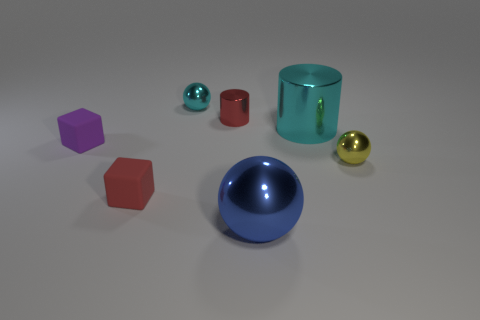What number of other things are there of the same color as the large metal cylinder?
Make the answer very short. 1. There is a tiny block that is the same color as the tiny cylinder; what is its material?
Provide a succinct answer. Rubber. How many tiny objects have the same color as the tiny shiny cylinder?
Your answer should be compact. 1. Does the large thing that is behind the small red cube have the same color as the sphere behind the big cylinder?
Give a very brief answer. Yes. There is a cylinder to the right of the red shiny cylinder; what is its size?
Make the answer very short. Large. Is there any other thing that has the same color as the big cylinder?
Ensure brevity in your answer.  Yes. There is a thing that is in front of the small matte thing that is in front of the purple object; is there a small sphere that is on the left side of it?
Offer a terse response. Yes. Does the ball that is on the left side of the big blue sphere have the same color as the large metal cylinder?
Offer a very short reply. Yes. What number of cubes are cyan things or tiny cyan metal objects?
Provide a succinct answer. 0. There is a tiny red object that is left of the metallic cylinder left of the large sphere; what shape is it?
Ensure brevity in your answer.  Cube. 